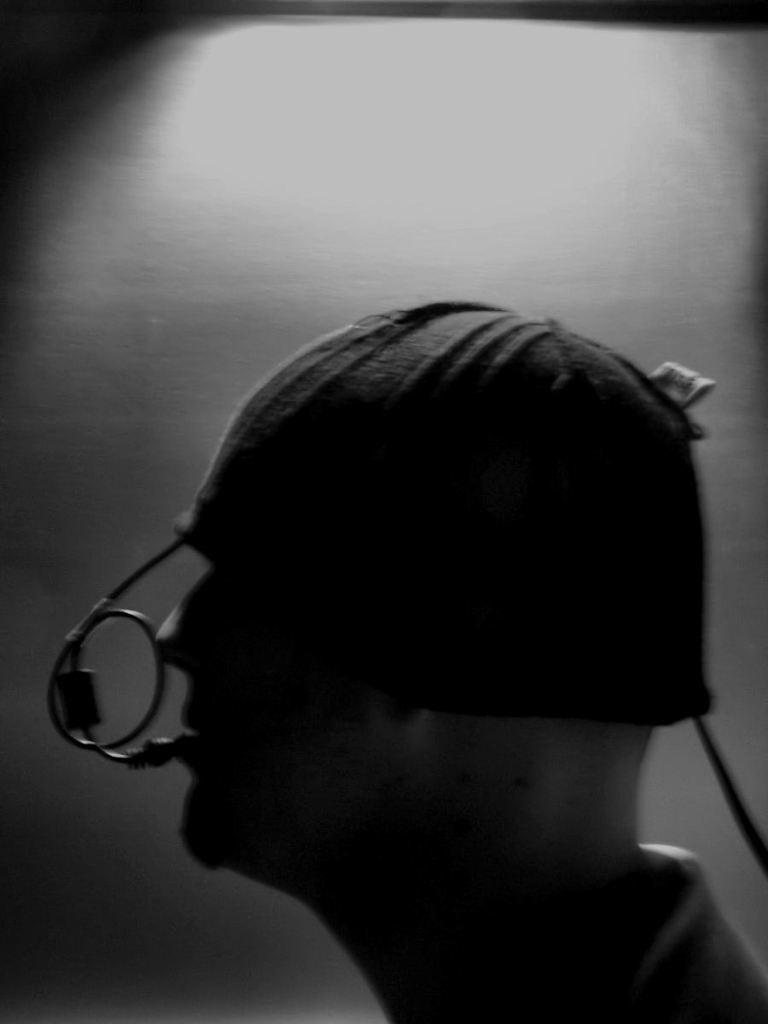What type of picture is in the image? The image contains a black and white picture of a person. What is the person in the picture wearing on their head? The person is wearing a black colored hat. What color is the wire visible in the image? The wire is black colored. What color is the background of the image? The background of the image includes a white colored surface. What type of experience does the person in the picture have with their family in the image? There is no information about the person's experience with their family in the image, as it only contains a black and white picture of a person wearing a hat. How does the person in the picture measure the length of the wire in the image? There is no indication that the person in the picture is measuring the length of the wire, as the image only shows a black and white picture of a person wearing a hat and a black colored wire. 